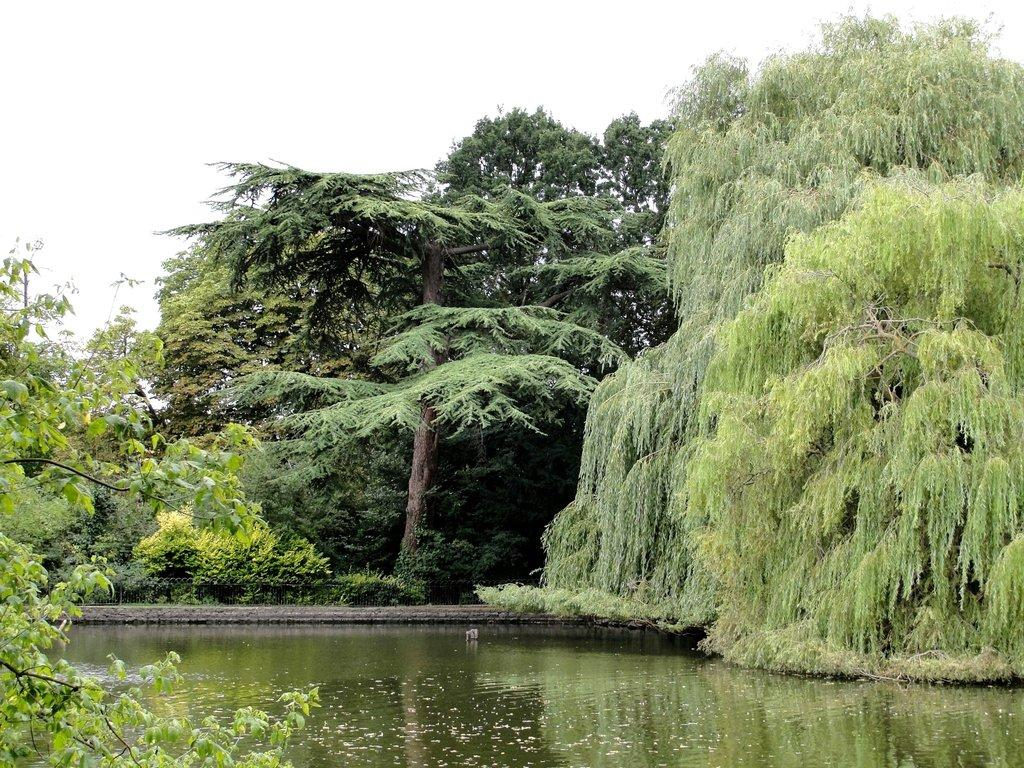What is visible in the image? Water, trees, and the sky are visible in the image. Can you describe the water in the image? The water is visible, but its specific characteristics are not mentioned in the facts. What type of vegetation is present in the image? Trees are present in the image. What can be seen in the background of the image? The sky is visible in the background of the image. What color is the orange in the image? There is no orange present in the image. What decision is being made in the image? The facts provided do not mention any decision-making process in the image. 